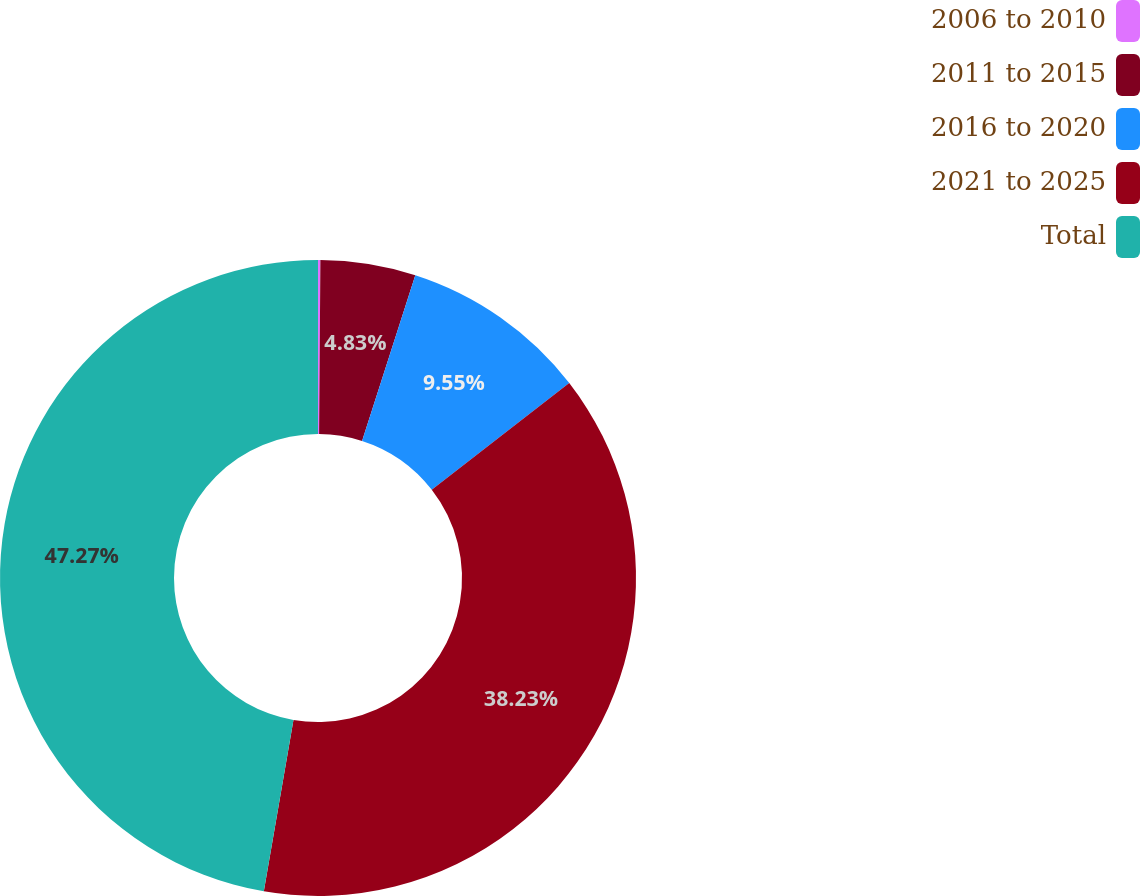Convert chart to OTSL. <chart><loc_0><loc_0><loc_500><loc_500><pie_chart><fcel>2006 to 2010<fcel>2011 to 2015<fcel>2016 to 2020<fcel>2021 to 2025<fcel>Total<nl><fcel>0.12%<fcel>4.83%<fcel>9.55%<fcel>38.23%<fcel>47.28%<nl></chart> 